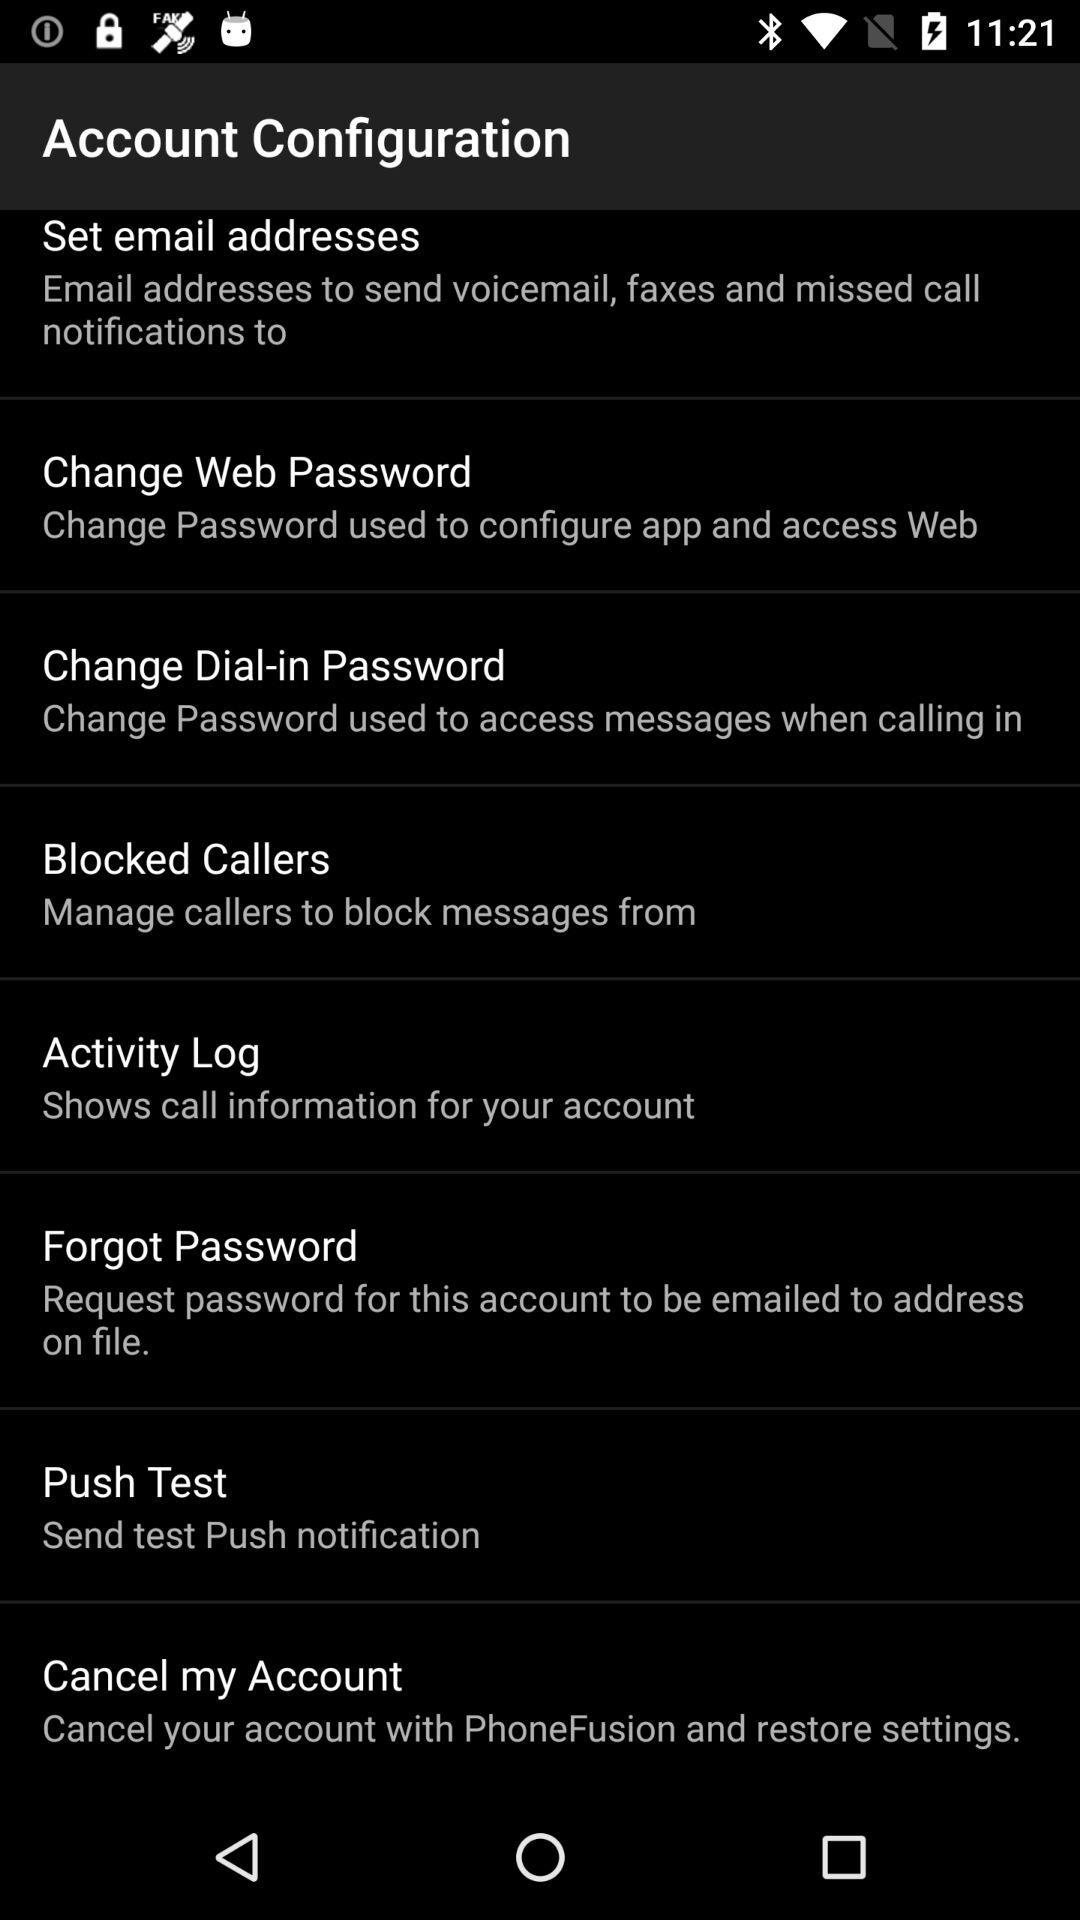Is "Push Test" checked or unchecked?
When the provided information is insufficient, respond with <no answer>. <no answer> 